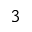<formula> <loc_0><loc_0><loc_500><loc_500>3</formula> 